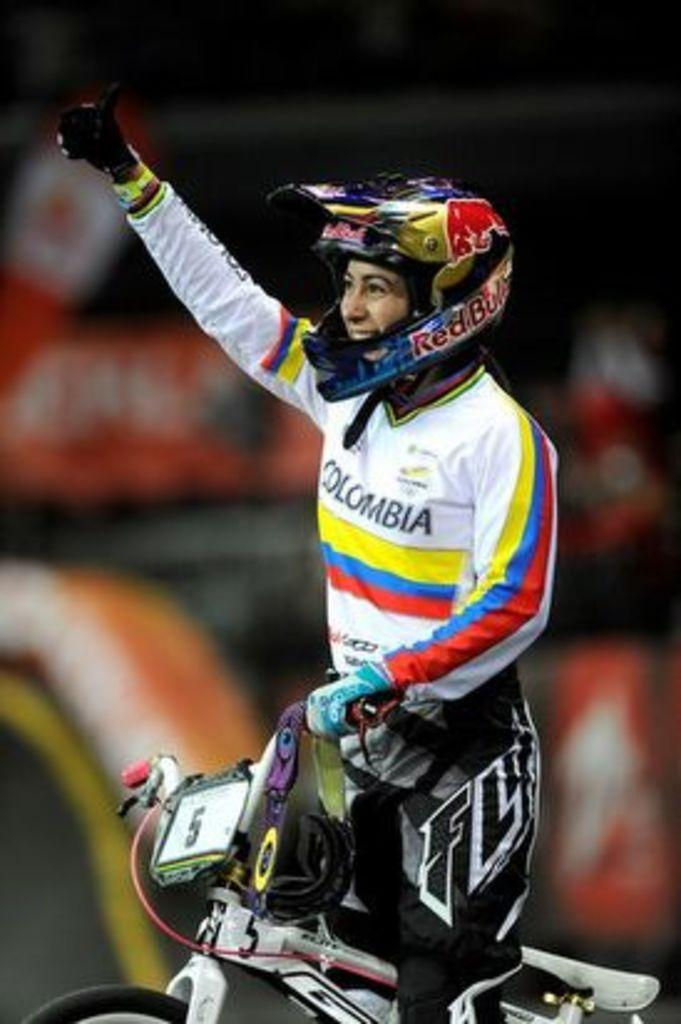Who or what is the main subject of the image? There is a person in the image. What is the person doing in the image? The person is on a bicycle. Where is the bicycle located in the image? The bicycle is in the center of the image. What type of arch can be seen in the background of the image? There is no arch present in the image; it only features a person on a bicycle. What company is associated with the desk in the image? There is no desk present in the image, so it cannot be associated with any company. 